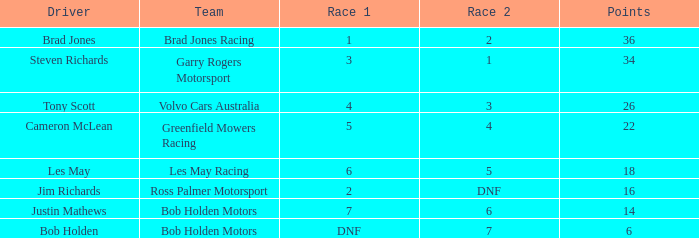Which driver for Greenfield Mowers Racing has fewer than 36 points? Cameron McLean. 